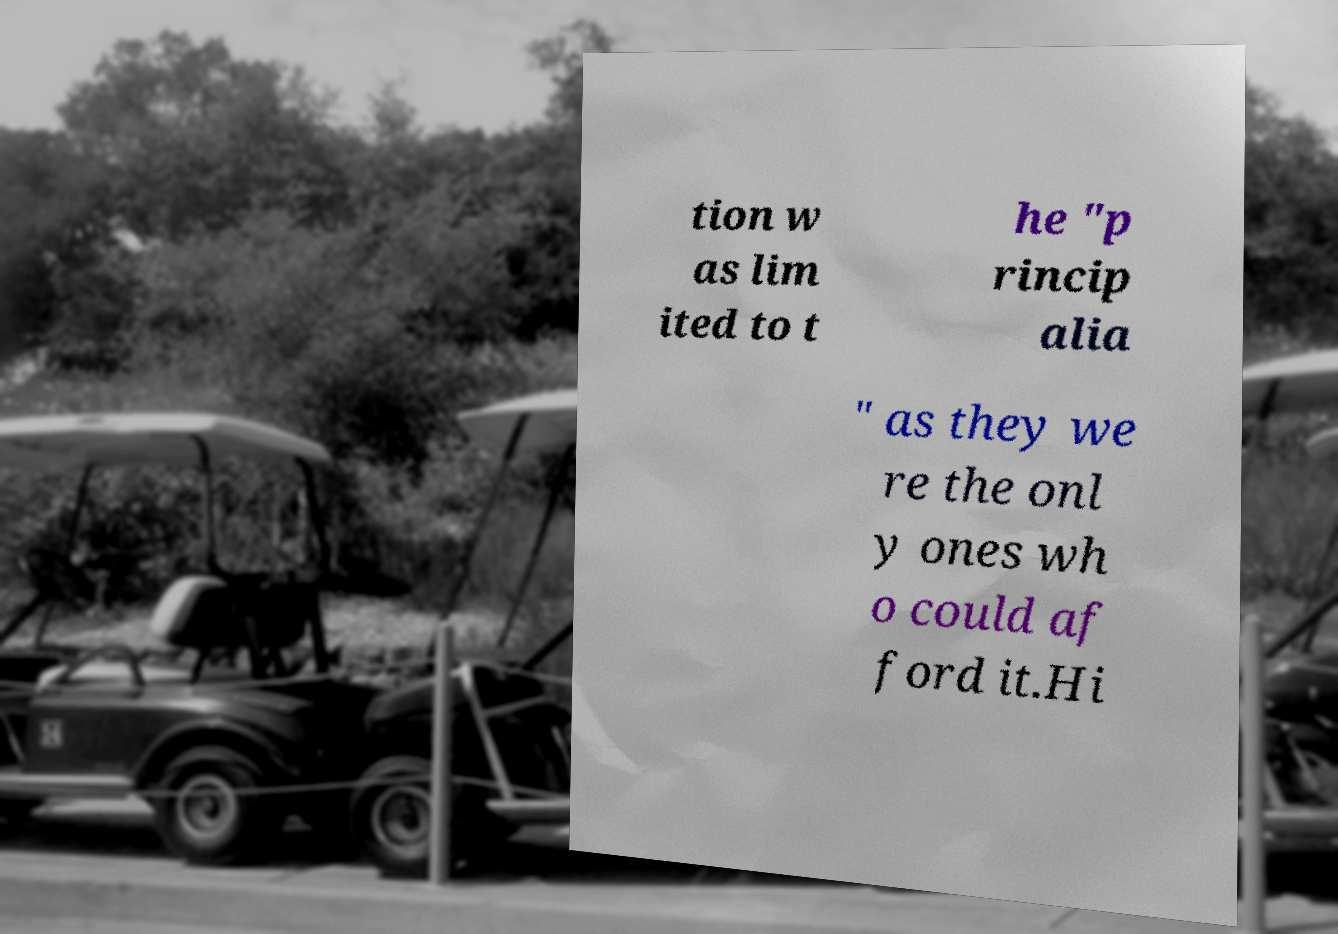There's text embedded in this image that I need extracted. Can you transcribe it verbatim? tion w as lim ited to t he "p rincip alia " as they we re the onl y ones wh o could af ford it.Hi 